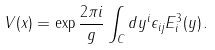Convert formula to latex. <formula><loc_0><loc_0><loc_500><loc_500>V ( x ) = \exp { \frac { 2 \pi i } { g } } \int _ { C } d y ^ { i } \epsilon _ { i j } E ^ { 3 } _ { i } ( y ) \, .</formula> 